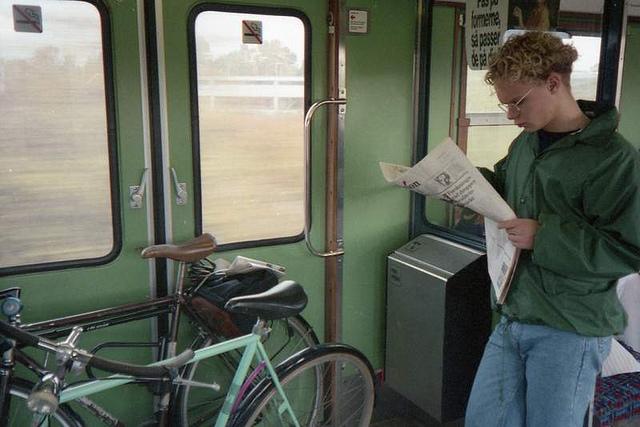What is the man reading?
Short answer required. Newspaper. What color is the bike in the foreground?
Answer briefly. Green. What color is the bike?
Quick response, please. Green. Is this man on the right standing near luggage?
Short answer required. No. How many spokes are on the rear bike wheel?
Keep it brief. 20. 